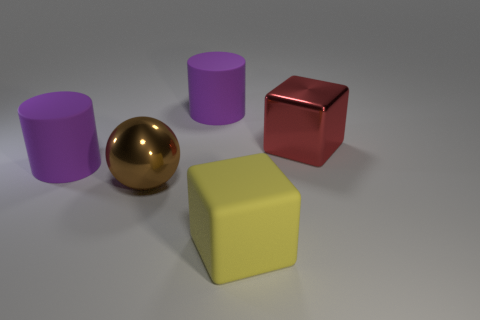Subtract all spheres. How many objects are left? 4 Add 1 cyan matte blocks. How many objects exist? 6 Add 3 brown metal spheres. How many brown metal spheres are left? 4 Add 2 small blue matte objects. How many small blue matte objects exist? 2 Subtract 0 gray balls. How many objects are left? 5 Subtract all large balls. Subtract all purple cylinders. How many objects are left? 2 